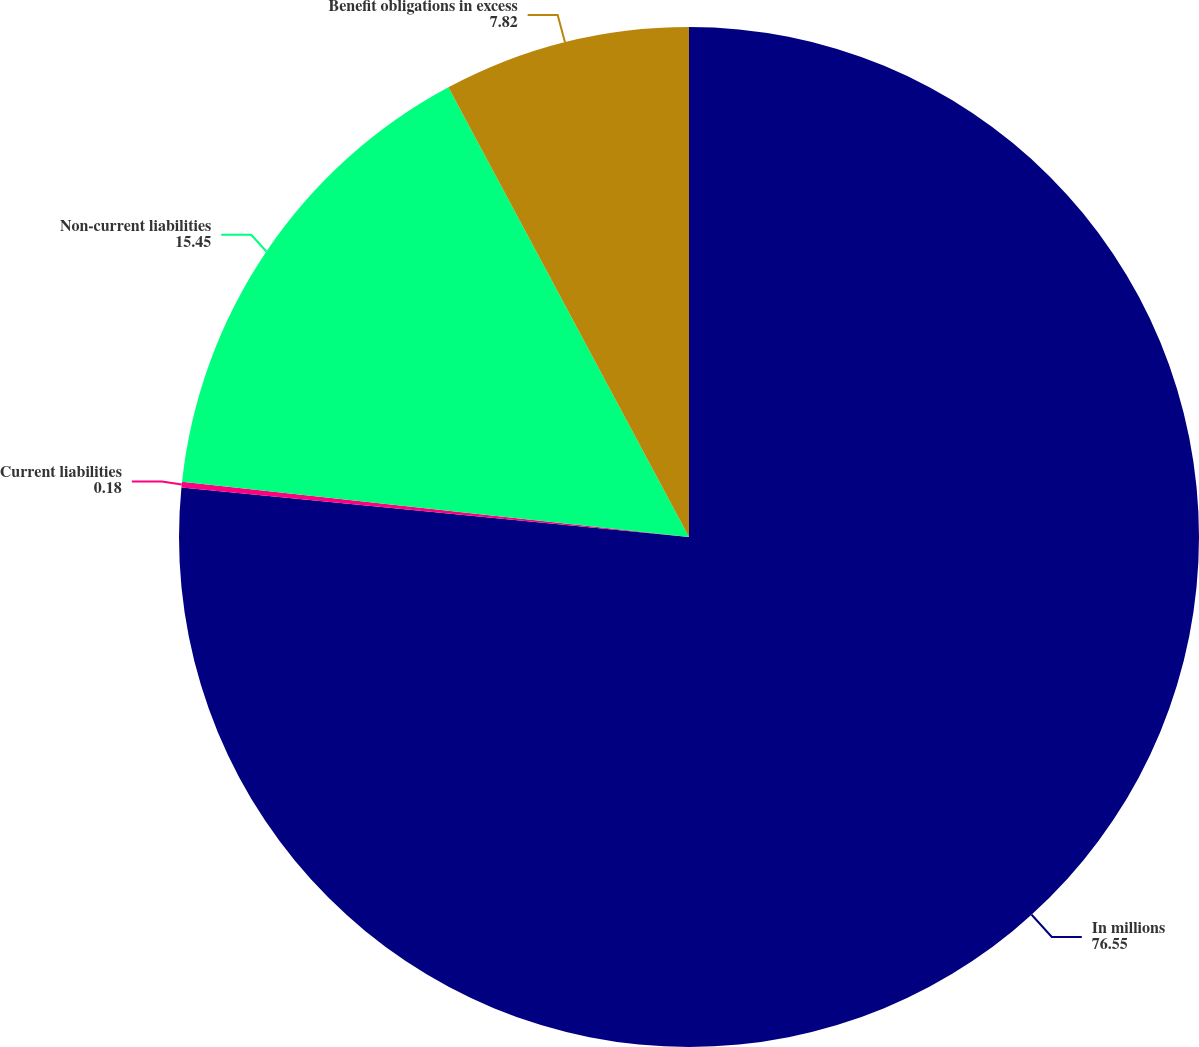Convert chart to OTSL. <chart><loc_0><loc_0><loc_500><loc_500><pie_chart><fcel>In millions<fcel>Current liabilities<fcel>Non-current liabilities<fcel>Benefit obligations in excess<nl><fcel>76.55%<fcel>0.18%<fcel>15.45%<fcel>7.82%<nl></chart> 